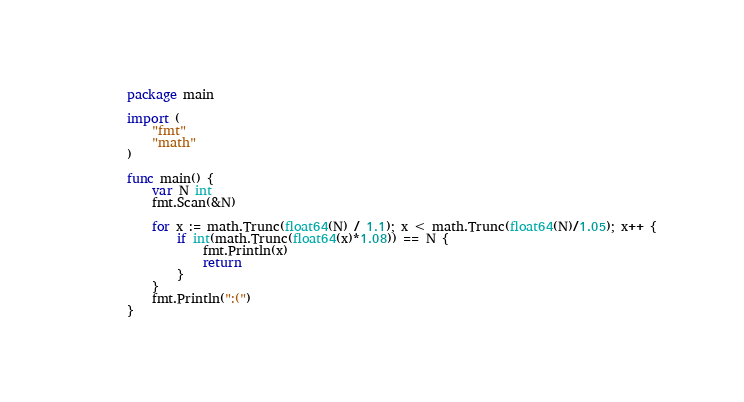Convert code to text. <code><loc_0><loc_0><loc_500><loc_500><_Go_>package main

import (
	"fmt"
	"math"
)

func main() {
	var N int
	fmt.Scan(&N)

	for x := math.Trunc(float64(N) / 1.1); x < math.Trunc(float64(N)/1.05); x++ {
		if int(math.Trunc(float64(x)*1.08)) == N {
			fmt.Println(x)
			return
		}
	}
	fmt.Println(":(")
}
</code> 